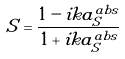<formula> <loc_0><loc_0><loc_500><loc_500>S = \frac { 1 - i k a _ { S } ^ { a b s } } { 1 + i k a _ { S } ^ { a b s } }</formula> 